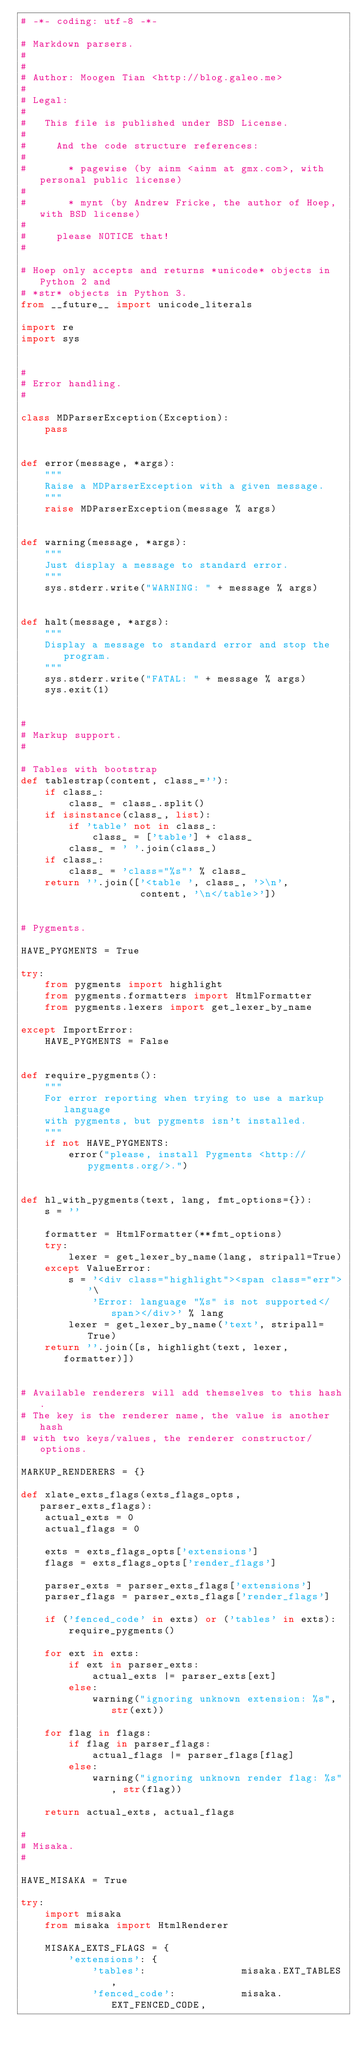Convert code to text. <code><loc_0><loc_0><loc_500><loc_500><_Python_># -*- coding: utf-8 -*-

# Markdown parsers.
#
#
# Author: Moogen Tian <http://blog.galeo.me>
#
# Legal:
#
#   This file is published under BSD License.
#
#     And the code structure references:
#
#       * pagewise (by ainm <ainm at gmx.com>, with personal public license)
#
#       * mynt (by Andrew Fricke, the author of Hoep, with BSD license)
#
#     please NOTICE that!
#

# Hoep only accepts and returns *unicode* objects in Python 2 and
# *str* objects in Python 3.
from __future__ import unicode_literals

import re
import sys


#
# Error handling.
#

class MDParserException(Exception):
    pass


def error(message, *args):
    """
    Raise a MDParserException with a given message.
    """
    raise MDParserException(message % args)


def warning(message, *args):
    """
    Just display a message to standard error.
    """
    sys.stderr.write("WARNING: " + message % args)


def halt(message, *args):
    """
    Display a message to standard error and stop the program.
    """
    sys.stderr.write("FATAL: " + message % args)
    sys.exit(1)


#
# Markup support.
#

# Tables with bootstrap
def tablestrap(content, class_=''):
    if class_:
        class_ = class_.split()
    if isinstance(class_, list):
        if 'table' not in class_:
            class_ = ['table'] + class_
        class_ = ' '.join(class_)
    if class_:
        class_ = 'class="%s"' % class_
    return ''.join(['<table ', class_, '>\n',
                    content, '\n</table>'])


# Pygments.

HAVE_PYGMENTS = True

try:
    from pygments import highlight
    from pygments.formatters import HtmlFormatter
    from pygments.lexers import get_lexer_by_name

except ImportError:
    HAVE_PYGMENTS = False


def require_pygments():
    """
    For error reporting when trying to use a markup language
    with pygments, but pygments isn't installed.
    """
    if not HAVE_PYGMENTS:
        error("please, install Pygments <http://pygments.org/>.")


def hl_with_pygments(text, lang, fmt_options={}):
    s = ''

    formatter = HtmlFormatter(**fmt_options)
    try:
        lexer = get_lexer_by_name(lang, stripall=True)
    except ValueError:
        s = '<div class="highlight"><span class="err">'\
            'Error: language "%s" is not supported</span></div>' % lang
        lexer = get_lexer_by_name('text', stripall=True)
    return ''.join([s, highlight(text, lexer, formatter)])


# Available renderers will add themselves to this hash.
# The key is the renderer name, the value is another hash
# with two keys/values, the renderer constructor/options.

MARKUP_RENDERERS = {}

def xlate_exts_flags(exts_flags_opts, parser_exts_flags):
    actual_exts = 0
    actual_flags = 0

    exts = exts_flags_opts['extensions']
    flags = exts_flags_opts['render_flags']

    parser_exts = parser_exts_flags['extensions']
    parser_flags = parser_exts_flags['render_flags']

    if ('fenced_code' in exts) or ('tables' in exts):
        require_pygments()

    for ext in exts:
        if ext in parser_exts:
            actual_exts |= parser_exts[ext]
        else:
            warning("ignoring unknown extension: %s", str(ext))

    for flag in flags:
        if flag in parser_flags:
            actual_flags |= parser_flags[flag]
        else:
            warning("ignoring unknown render flag: %s", str(flag))

    return actual_exts, actual_flags

#
# Misaka.
#

HAVE_MISAKA = True

try:
    import misaka
    from misaka import HtmlRenderer

    MISAKA_EXTS_FLAGS = {
        'extensions': {
            'tables':                misaka.EXT_TABLES,
            'fenced_code':           misaka.EXT_FENCED_CODE,</code> 